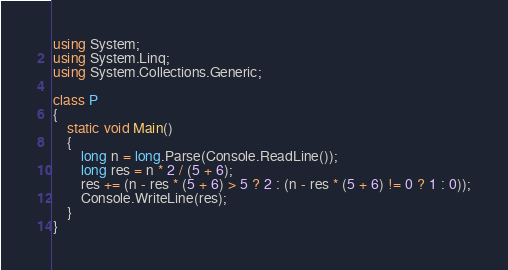Convert code to text. <code><loc_0><loc_0><loc_500><loc_500><_C#_>using System;
using System.Linq;
using System.Collections.Generic;

class P
{
    static void Main()
    {
        long n = long.Parse(Console.ReadLine());
        long res = n * 2 / (5 + 6);
        res += (n - res * (5 + 6) > 5 ? 2 : (n - res * (5 + 6) != 0 ? 1 : 0));
        Console.WriteLine(res);
    }
}</code> 